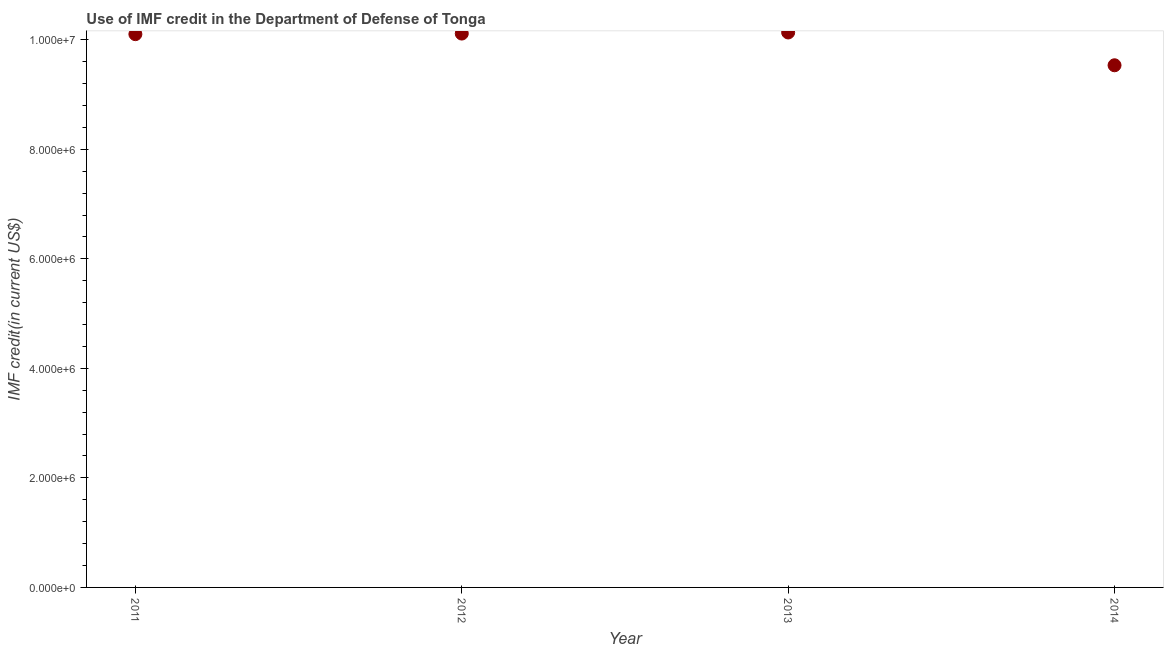What is the use of imf credit in dod in 2014?
Offer a very short reply. 9.54e+06. Across all years, what is the maximum use of imf credit in dod?
Provide a succinct answer. 1.01e+07. Across all years, what is the minimum use of imf credit in dod?
Provide a succinct answer. 9.54e+06. In which year was the use of imf credit in dod maximum?
Make the answer very short. 2013. What is the sum of the use of imf credit in dod?
Give a very brief answer. 3.99e+07. What is the difference between the use of imf credit in dod in 2013 and 2014?
Provide a succinct answer. 5.99e+05. What is the average use of imf credit in dod per year?
Provide a succinct answer. 9.97e+06. What is the median use of imf credit in dod?
Make the answer very short. 1.01e+07. In how many years, is the use of imf credit in dod greater than 4000000 US$?
Keep it short and to the point. 4. What is the ratio of the use of imf credit in dod in 2013 to that in 2014?
Give a very brief answer. 1.06. What is the difference between the highest and the lowest use of imf credit in dod?
Offer a very short reply. 5.99e+05. In how many years, is the use of imf credit in dod greater than the average use of imf credit in dod taken over all years?
Give a very brief answer. 3. Does the use of imf credit in dod monotonically increase over the years?
Provide a short and direct response. No. How many dotlines are there?
Offer a very short reply. 1. What is the difference between two consecutive major ticks on the Y-axis?
Offer a terse response. 2.00e+06. Are the values on the major ticks of Y-axis written in scientific E-notation?
Offer a terse response. Yes. Does the graph contain grids?
Provide a short and direct response. No. What is the title of the graph?
Ensure brevity in your answer.  Use of IMF credit in the Department of Defense of Tonga. What is the label or title of the Y-axis?
Your answer should be very brief. IMF credit(in current US$). What is the IMF credit(in current US$) in 2011?
Provide a short and direct response. 1.01e+07. What is the IMF credit(in current US$) in 2012?
Ensure brevity in your answer.  1.01e+07. What is the IMF credit(in current US$) in 2013?
Provide a short and direct response. 1.01e+07. What is the IMF credit(in current US$) in 2014?
Provide a short and direct response. 9.54e+06. What is the difference between the IMF credit(in current US$) in 2011 and 2012?
Ensure brevity in your answer.  -1.10e+04. What is the difference between the IMF credit(in current US$) in 2011 and 2013?
Provide a succinct answer. -3.10e+04. What is the difference between the IMF credit(in current US$) in 2011 and 2014?
Your answer should be compact. 5.68e+05. What is the difference between the IMF credit(in current US$) in 2012 and 2014?
Give a very brief answer. 5.79e+05. What is the difference between the IMF credit(in current US$) in 2013 and 2014?
Give a very brief answer. 5.99e+05. What is the ratio of the IMF credit(in current US$) in 2011 to that in 2012?
Offer a very short reply. 1. What is the ratio of the IMF credit(in current US$) in 2011 to that in 2013?
Offer a very short reply. 1. What is the ratio of the IMF credit(in current US$) in 2011 to that in 2014?
Ensure brevity in your answer.  1.06. What is the ratio of the IMF credit(in current US$) in 2012 to that in 2013?
Give a very brief answer. 1. What is the ratio of the IMF credit(in current US$) in 2012 to that in 2014?
Keep it short and to the point. 1.06. What is the ratio of the IMF credit(in current US$) in 2013 to that in 2014?
Give a very brief answer. 1.06. 